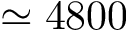<formula> <loc_0><loc_0><loc_500><loc_500>\simeq 4 8 0 0</formula> 